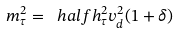Convert formula to latex. <formula><loc_0><loc_0><loc_500><loc_500>m _ { \tau } ^ { 2 } = \ h a l f h _ { \tau } ^ { 2 } v _ { d } ^ { 2 } ( 1 + \delta )</formula> 